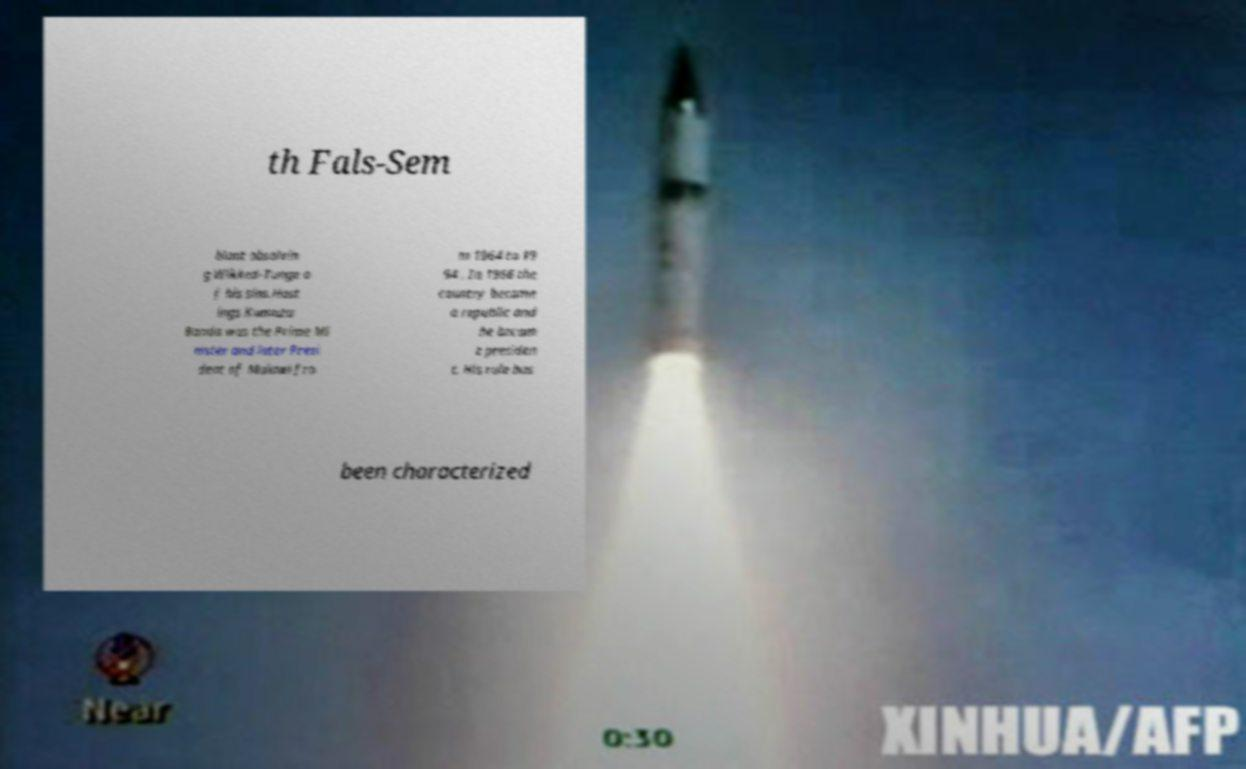Please read and relay the text visible in this image. What does it say? th Fals-Sem blant absolvin g Wikked-Tunge o f his sins.Hast ings Kamuzu Banda was the Prime Mi nister and later Presi dent of Malawi fro m 1964 to 19 94 . In 1966 the country became a republic and he becam e presiden t. His rule has been characterized 